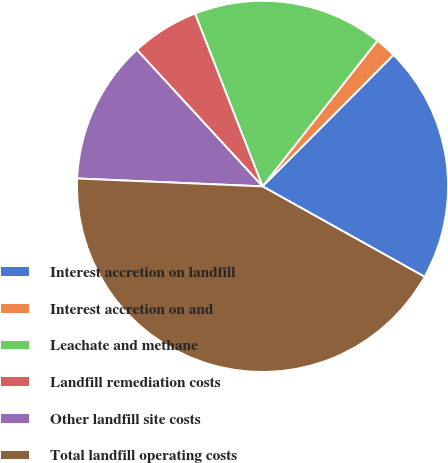Convert chart to OTSL. <chart><loc_0><loc_0><loc_500><loc_500><pie_chart><fcel>Interest accretion on landfill<fcel>Interest accretion on and<fcel>Leachate and methane<fcel>Landfill remediation costs<fcel>Other landfill site costs<fcel>Total landfill operating costs<nl><fcel>20.63%<fcel>1.84%<fcel>16.56%<fcel>5.91%<fcel>12.48%<fcel>42.58%<nl></chart> 